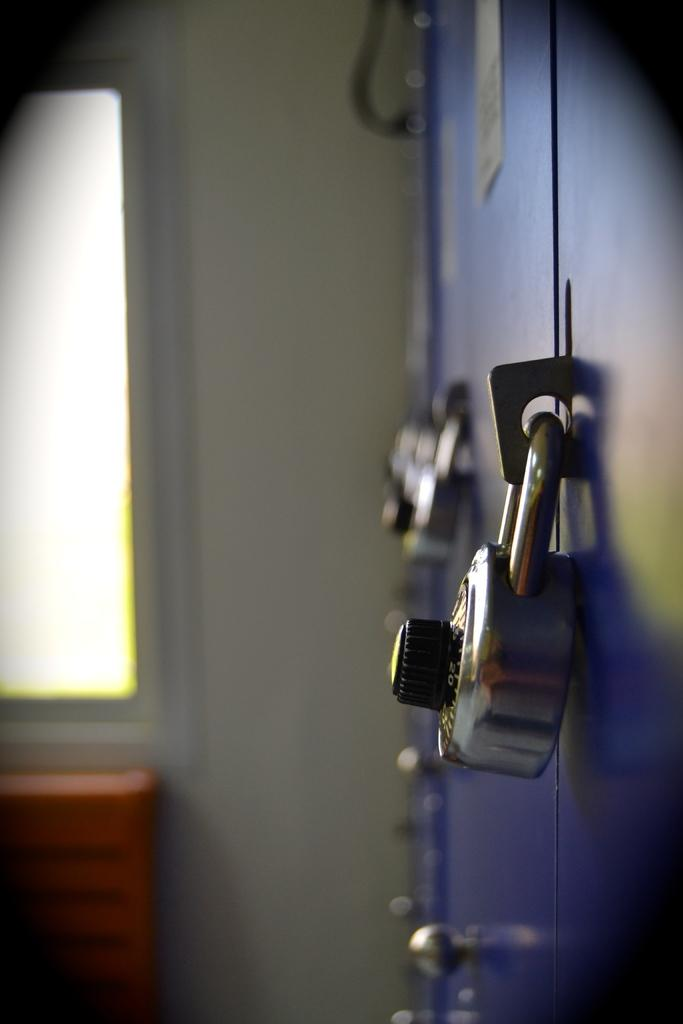What type of storage units are in the image? There are lockers in the image. How are the lockers secured? The lockers have locks. What is on the left side of the lockers? There is a wall on the left side of the lockers. What feature is present on the wall? There is a window on the wall. What object can be seen on the wall? There is an object on the wall. Can you see any mountains in the image? There are no mountains visible in the image. What type of pest is crawling on the lockers in the image? There are no pests present in the image. 